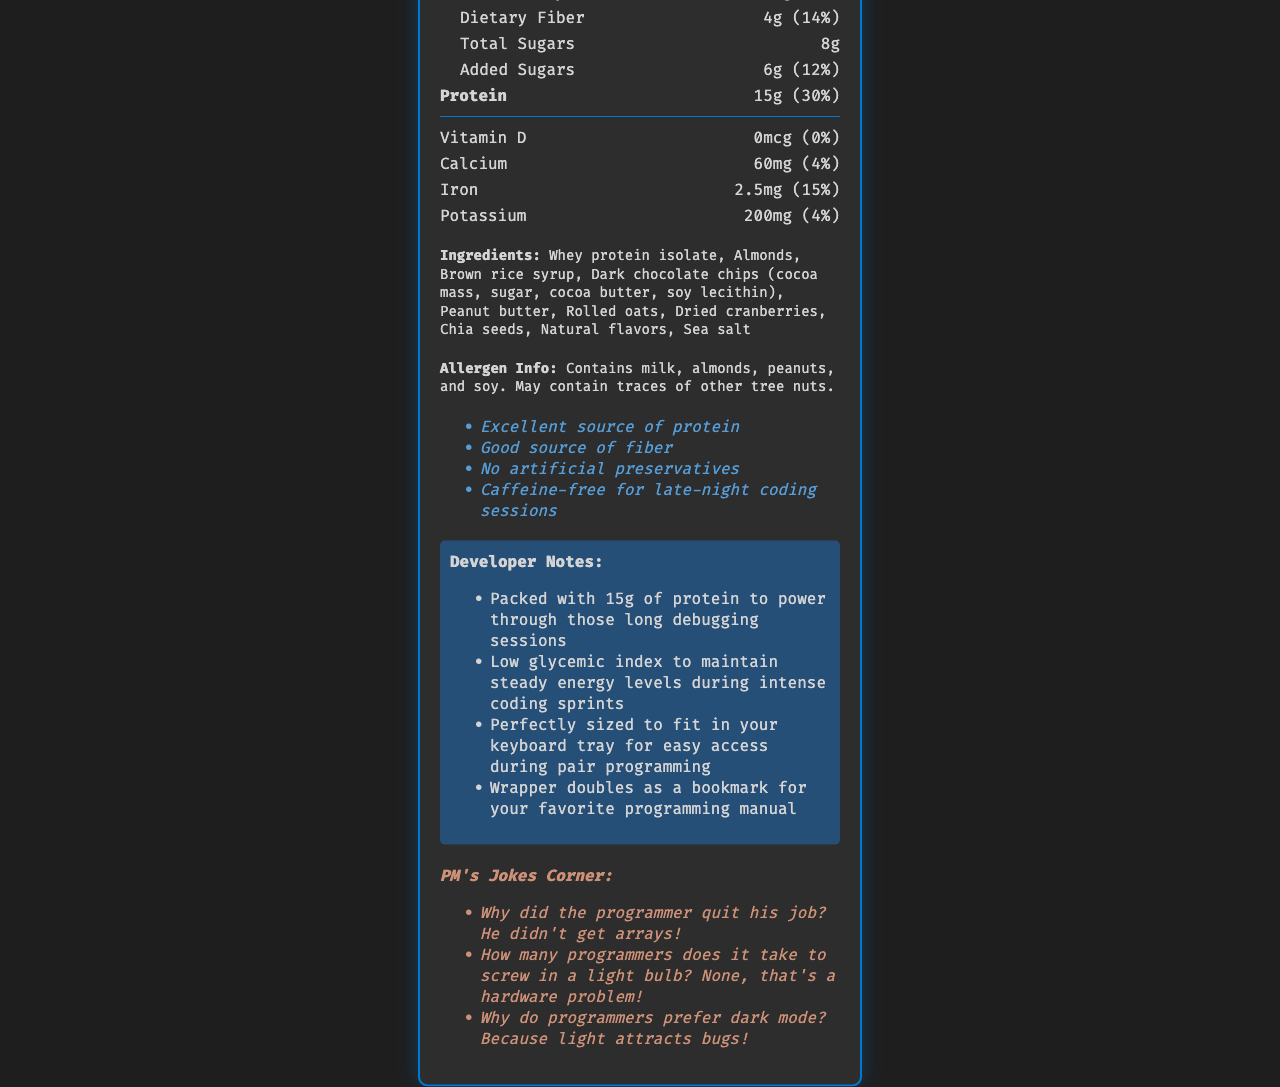what is the serving size of Bug Fix Bites? The serving size is directly stated in the document as "1 bar (60g)".
Answer: 1 bar (60g) how many calories are there per serving? The calories per serving are listed as 240 in the document.
Answer: 240 calories what is the total fat content in one serving? The document indicates that the total fat content in one serving is 12 grams.
Answer: 12g how much protein does a single Bug Fix Bite provide? The protein amount per serving is given as 15 grams in the document.
Answer: 15g what is the amount of dietary fiber per serving and its percent daily value? The dietary fiber amount is 4 grams, contributing to 14% of the daily value.
Answer: 4g, 14% how much sodium is there in Bug Fix Bites? The sodium content is listed as 180 milligrams per serving.
Answer: 180mg which vitamin has no daily value provided? A. Vitamin D B. Calcium C. Iron D. Potassium The document states the vitamin D amount is 0mcg, with a daily value of 0%.
Answer: A. Vitamin D what is the primary ingredient in Bug Fix Bites? A. Almonds B. Whey protein isolate C. Brown rice syrup D. Dark chocolate chips The first ingredient listed is Whey protein isolate, making it the primary ingredient.
Answer: B. Whey protein isolate which of the following statements is true regarding the added sugars in Bug Fix Bites? A. There are no added sugars. B. They contain 6g of added sugars. C. Added sugars make up 20% of daily value. D. They contain only natural sugars. The document notes that Bug Fix Bites contain 6 grams of added sugars, contributing to 12% of daily value.
Answer: B. They contain 6g of added sugars. do Bug Fix Bites contain any artificial preservatives? One of the claim statements explicitly mentions "No artificial preservatives".
Answer: No summarize the main nutritional highlights of Bug Fix Bites. This summary encapsulates the key nutritional aspects described in the nutrition facts and claim statements of Bug Fix Bites.
Answer: Bug Fix Bites are a protein-packed snack bar with 15 grams of protein per serving. Each bar (60g) contains 240 calories, 12 grams of total fat (including 3 grams of saturated fat), 24 grams of carbohydrates, 4 grams of dietary fiber, and 8 grams of total sugars (including 6 grams of added sugars). They are an excellent source of protein and a good source of fiber, with no artificial preservatives and are caffeine-free. how many developers contributed to creating Bug Fix Bites? The document does not provide any information about the number of developers involved in creating the product.
Answer: Cannot be determined 